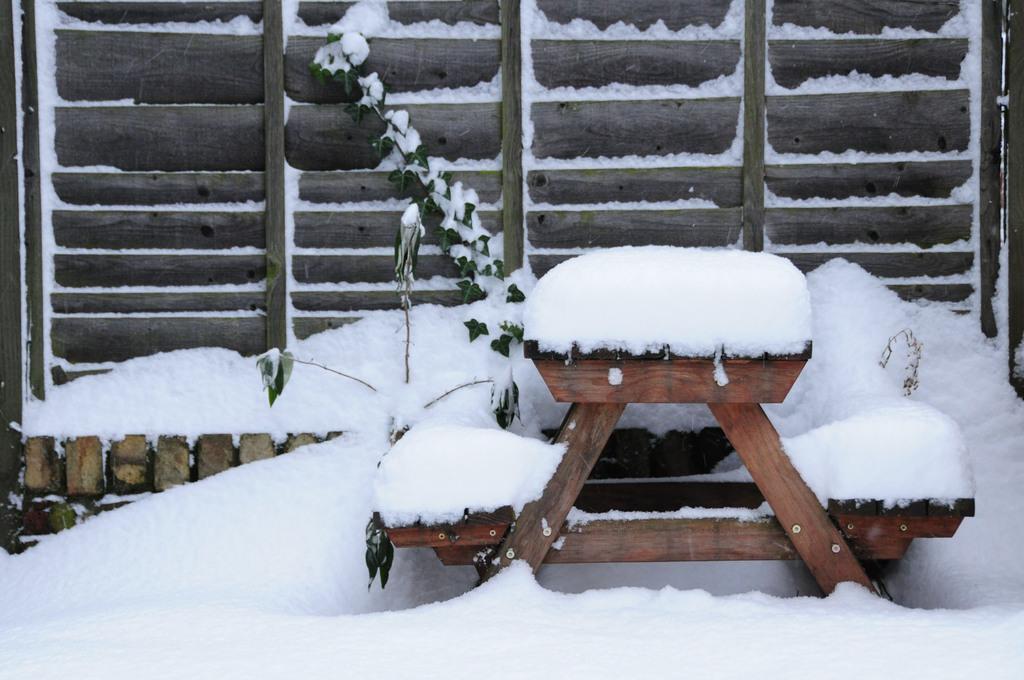Can you describe this image briefly? In the center of the image there is a wooden table. At the bottom of the image there is snow. In the background of the image there is a gate. 